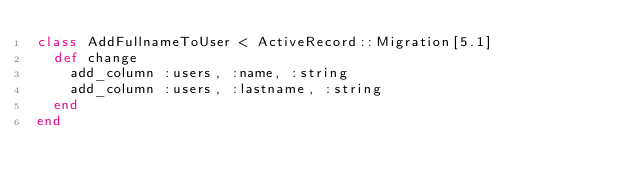<code> <loc_0><loc_0><loc_500><loc_500><_Ruby_>class AddFullnameToUser < ActiveRecord::Migration[5.1]
  def change
    add_column :users, :name, :string
    add_column :users, :lastname, :string
  end
end
</code> 